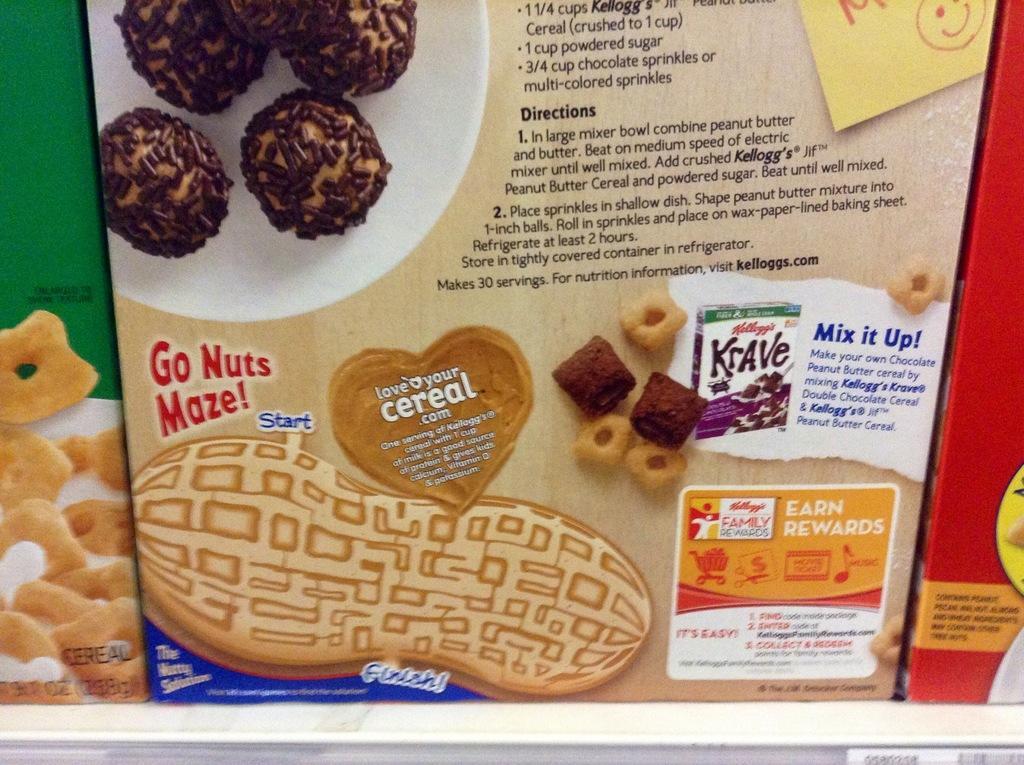Describe this image in one or two sentences. In this image I can see few boxes and they are in multi color and I can also see few chocolates and something written on the boxes. 